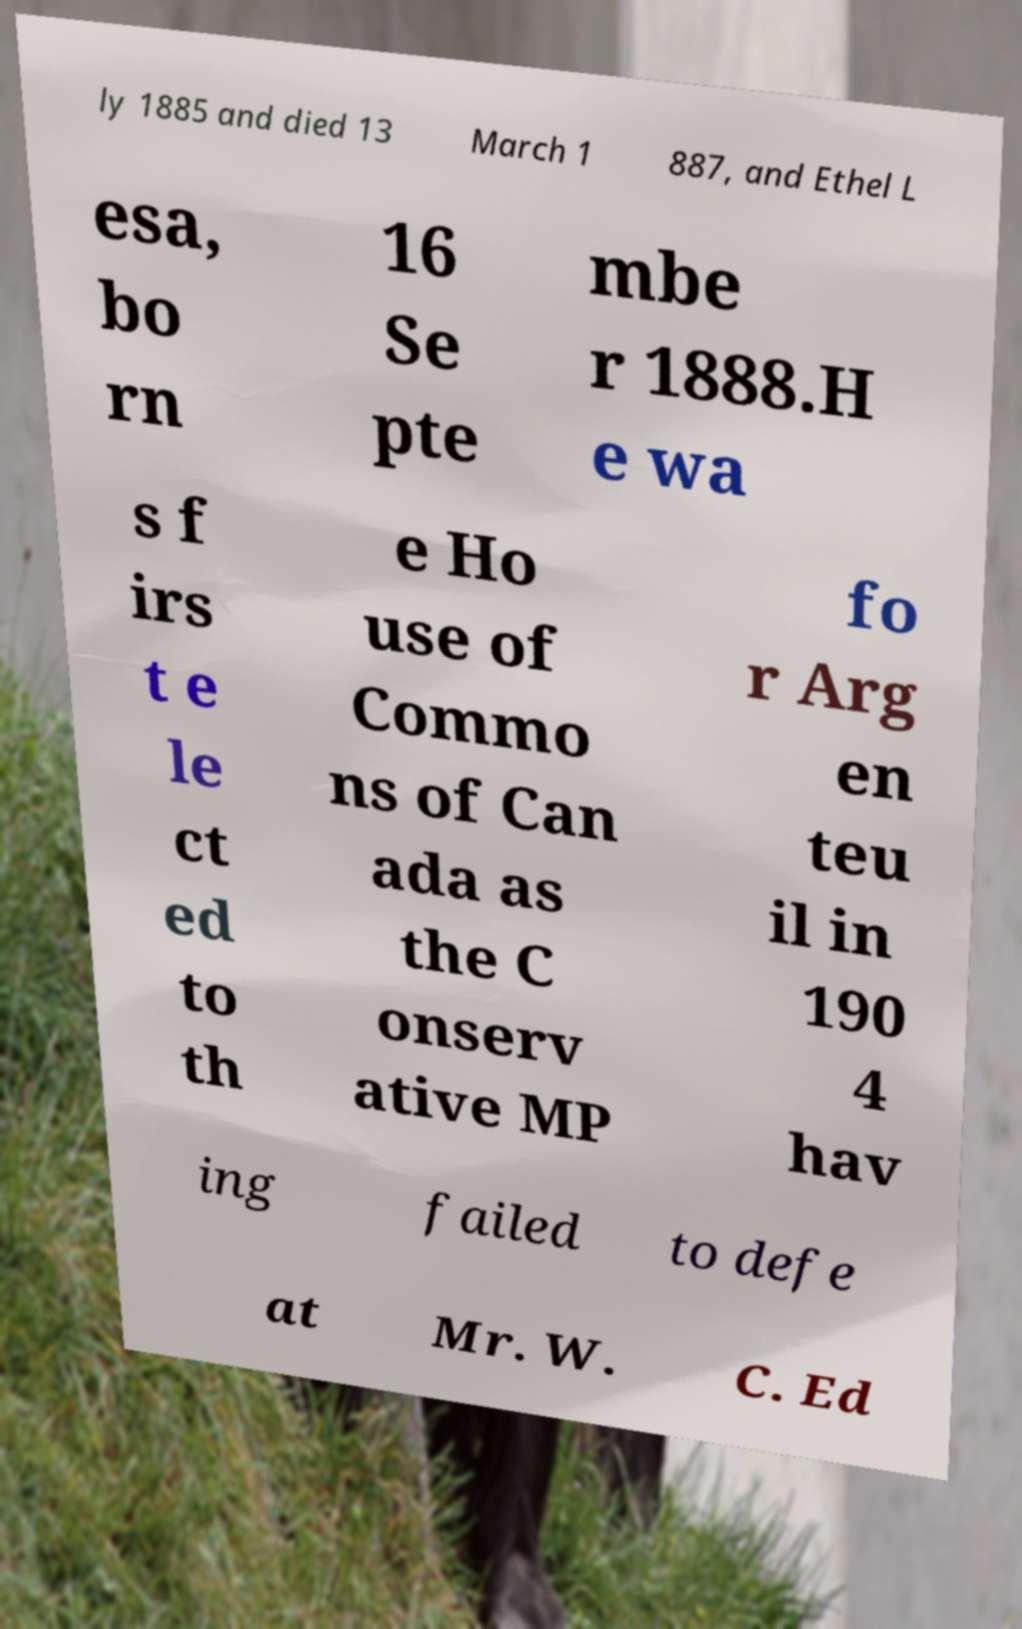Please identify and transcribe the text found in this image. ly 1885 and died 13 March 1 887, and Ethel L esa, bo rn 16 Se pte mbe r 1888.H e wa s f irs t e le ct ed to th e Ho use of Commo ns of Can ada as the C onserv ative MP fo r Arg en teu il in 190 4 hav ing failed to defe at Mr. W. C. Ed 